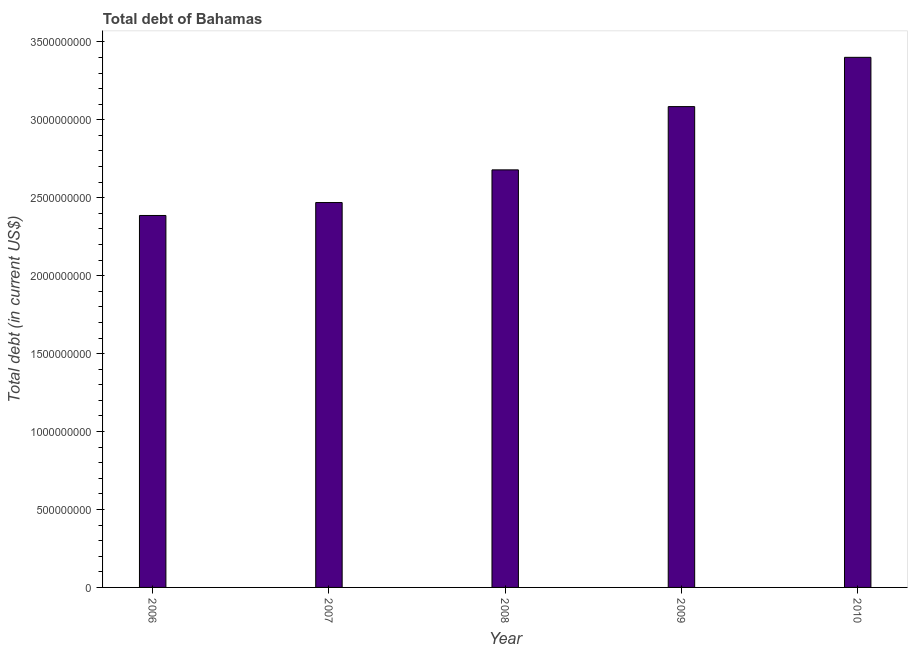Does the graph contain any zero values?
Make the answer very short. No. What is the title of the graph?
Make the answer very short. Total debt of Bahamas. What is the label or title of the X-axis?
Offer a terse response. Year. What is the label or title of the Y-axis?
Offer a terse response. Total debt (in current US$). What is the total debt in 2009?
Provide a short and direct response. 3.08e+09. Across all years, what is the maximum total debt?
Provide a succinct answer. 3.40e+09. Across all years, what is the minimum total debt?
Your response must be concise. 2.39e+09. In which year was the total debt minimum?
Ensure brevity in your answer.  2006. What is the sum of the total debt?
Provide a short and direct response. 1.40e+1. What is the difference between the total debt in 2006 and 2010?
Provide a succinct answer. -1.01e+09. What is the average total debt per year?
Your response must be concise. 2.80e+09. What is the median total debt?
Give a very brief answer. 2.68e+09. In how many years, is the total debt greater than 600000000 US$?
Provide a short and direct response. 5. What is the ratio of the total debt in 2008 to that in 2009?
Ensure brevity in your answer.  0.87. Is the total debt in 2007 less than that in 2008?
Your answer should be compact. Yes. Is the difference between the total debt in 2008 and 2010 greater than the difference between any two years?
Your answer should be compact. No. What is the difference between the highest and the second highest total debt?
Give a very brief answer. 3.16e+08. Is the sum of the total debt in 2007 and 2009 greater than the maximum total debt across all years?
Keep it short and to the point. Yes. What is the difference between the highest and the lowest total debt?
Provide a succinct answer. 1.01e+09. In how many years, is the total debt greater than the average total debt taken over all years?
Offer a very short reply. 2. How many bars are there?
Your answer should be very brief. 5. Are the values on the major ticks of Y-axis written in scientific E-notation?
Offer a terse response. No. What is the Total debt (in current US$) in 2006?
Your answer should be very brief. 2.39e+09. What is the Total debt (in current US$) of 2007?
Your answer should be very brief. 2.47e+09. What is the Total debt (in current US$) of 2008?
Provide a short and direct response. 2.68e+09. What is the Total debt (in current US$) of 2009?
Offer a very short reply. 3.08e+09. What is the Total debt (in current US$) of 2010?
Your response must be concise. 3.40e+09. What is the difference between the Total debt (in current US$) in 2006 and 2007?
Keep it short and to the point. -8.30e+07. What is the difference between the Total debt (in current US$) in 2006 and 2008?
Your answer should be very brief. -2.93e+08. What is the difference between the Total debt (in current US$) in 2006 and 2009?
Provide a succinct answer. -6.98e+08. What is the difference between the Total debt (in current US$) in 2006 and 2010?
Keep it short and to the point. -1.01e+09. What is the difference between the Total debt (in current US$) in 2007 and 2008?
Provide a short and direct response. -2.10e+08. What is the difference between the Total debt (in current US$) in 2007 and 2009?
Give a very brief answer. -6.15e+08. What is the difference between the Total debt (in current US$) in 2007 and 2010?
Your answer should be compact. -9.32e+08. What is the difference between the Total debt (in current US$) in 2008 and 2009?
Offer a very short reply. -4.06e+08. What is the difference between the Total debt (in current US$) in 2008 and 2010?
Your answer should be very brief. -7.22e+08. What is the difference between the Total debt (in current US$) in 2009 and 2010?
Your response must be concise. -3.16e+08. What is the ratio of the Total debt (in current US$) in 2006 to that in 2008?
Your response must be concise. 0.89. What is the ratio of the Total debt (in current US$) in 2006 to that in 2009?
Ensure brevity in your answer.  0.77. What is the ratio of the Total debt (in current US$) in 2006 to that in 2010?
Make the answer very short. 0.7. What is the ratio of the Total debt (in current US$) in 2007 to that in 2008?
Offer a terse response. 0.92. What is the ratio of the Total debt (in current US$) in 2007 to that in 2010?
Provide a succinct answer. 0.73. What is the ratio of the Total debt (in current US$) in 2008 to that in 2009?
Ensure brevity in your answer.  0.87. What is the ratio of the Total debt (in current US$) in 2008 to that in 2010?
Provide a short and direct response. 0.79. What is the ratio of the Total debt (in current US$) in 2009 to that in 2010?
Keep it short and to the point. 0.91. 